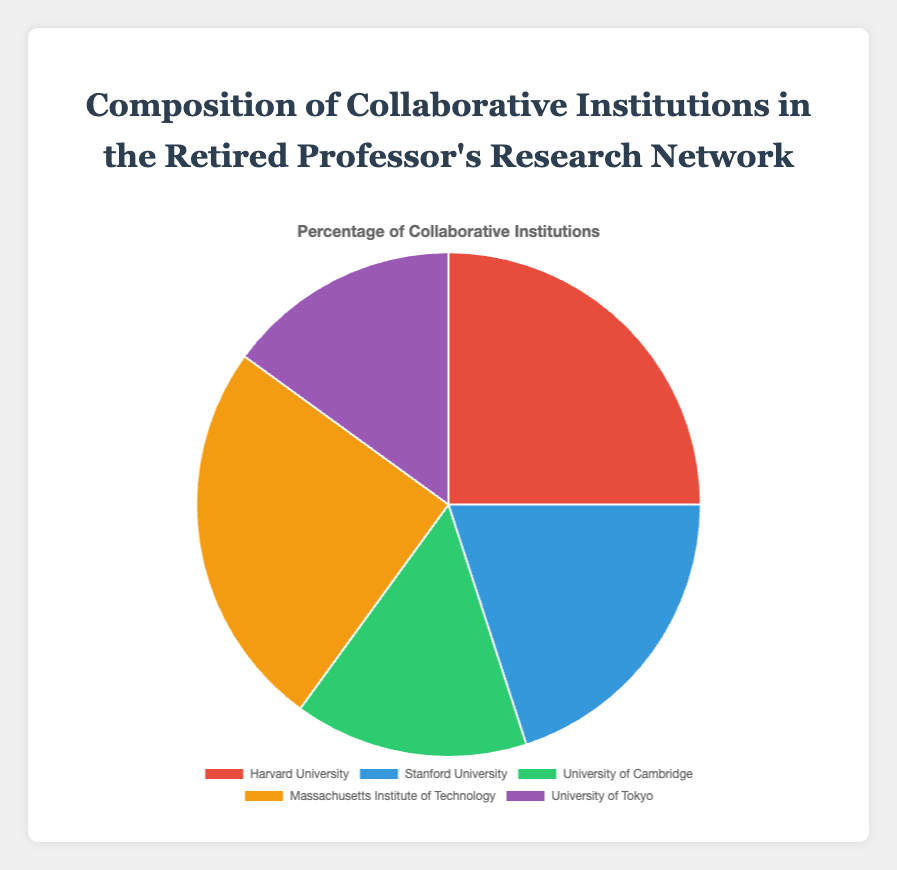What percentage of the collaborative institutions are attributed to universities other than Harvard or MIT? Harvard and MIT each contribute 25%. Together, they account for 50% (25% + 25%). Therefore, other universities contribute 100% - 50% = 50%.
Answer: 50% Which university has the lowest percentage of collaboration? The University of Cambridge and the University of Tokyo each account for 15%, which is the lowest percentage among the given institutions.
Answer: University of Cambridge and University of Tokyo How much higher is the collaboration percentage with Harvard than with Stanford? Harvard has a 25% collaboration rate, while Stanford has 20%. The difference is 25% - 20% = 5%.
Answer: 5% What fraction of the research collaborations involve either Stanford or the University of Tokyo? Stanford has 20% and the University of Tokyo has 15%. Combined, they contribute 20% + 15% = 35%, which as a fraction of 100% is 35/100 = 7/20.
Answer: 7/20 Compare the combined percentage of collaborations between MIT and the University of Cambridge to those between Stanford and the University of Tokyo. Which combination is larger? MIT and the University of Cambridge together account for 25% + 15% = 40%. Stanford and the University of Tokyo account for 20% + 15% = 35%. Thus, the combination of MIT and the University of Cambridge is larger.
Answer: MIT and University of Cambridge Identify the university represented by the green segment in the pie chart. The green segment in the pie chart represents the University of Cambridge, which has a 15% collaboration percentage.
Answer: University of Cambridge If the professor's collaborative work is evenly split over 5 years, what percentage of the collaborations per year does each institution represent, assuming collaborations are distributed according to the chart? For a yearly breakdown: Harvard and MIT account for 25%, divided equally over 5 years gives 25% / 5 = 5% per year. Stanford accounts for 20% / 5 = 4% per year. University of Cambridge and University of Tokyo each have 15% / 5 = 3% per year.
Answer: Harvard and MIT: 5% per year, Stanford: 4% per year, University of Cambridge and University of Tokyo: 3% per year Calculate the difference between the highest and the lowest collaboration percentages among the institutions. The highest collaboration percentages are 25% (Harvard and MIT). The lowest percentages are 15% (University of Cambridge and University of Tokyo). The difference is 25% - 15% = 10%.
Answer: 10% 